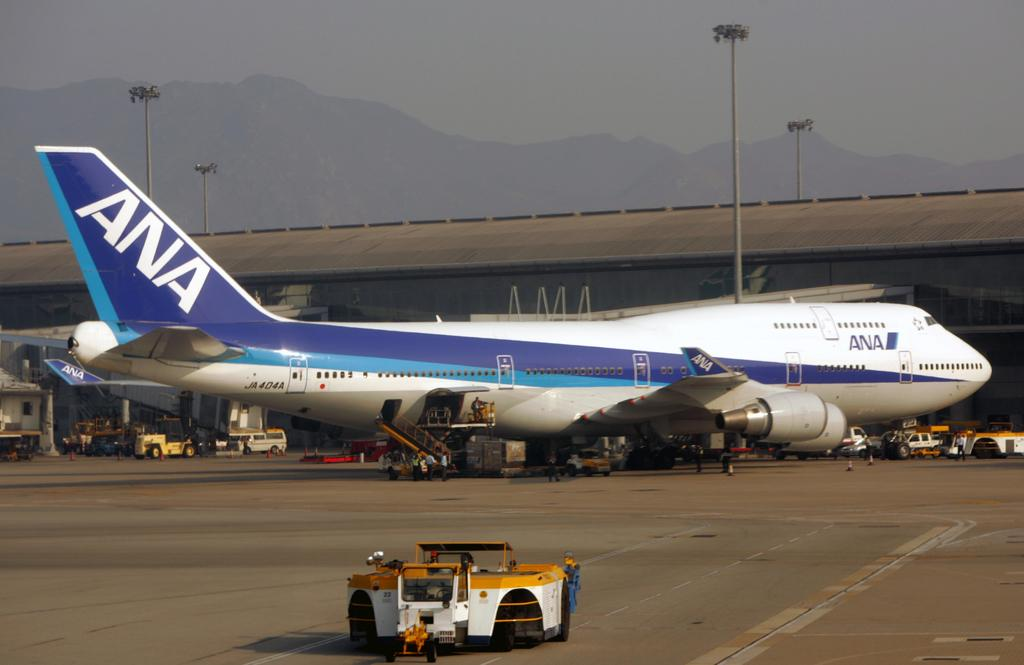What is the main subject of the image? The main subject of the image is an aircraft. Can you describe the colors of the aircraft? The aircraft has white, blue, and purple colors. What else can be seen in the image besides the aircraft? There are vehicles, people, stairs, light poles, mountains, and objects on the ground in the image. What type of substance is causing the earthquake in the image? There is no earthquake present in the image, so it is not possible to determine what substance might be causing it. 